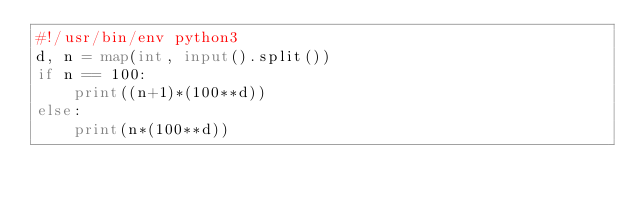Convert code to text. <code><loc_0><loc_0><loc_500><loc_500><_Python_>#!/usr/bin/env python3
d, n = map(int, input().split())
if n == 100:
    print((n+1)*(100**d))
else:
    print(n*(100**d))
</code> 